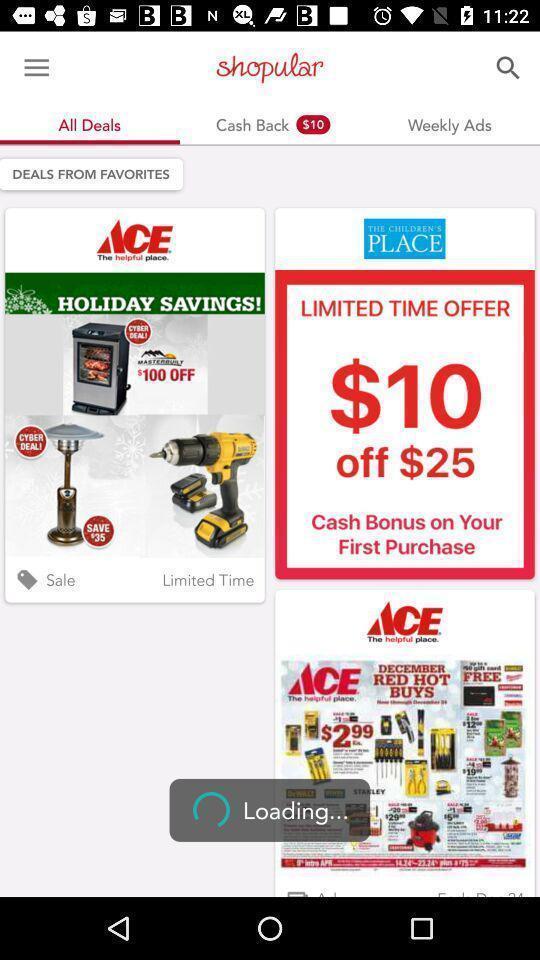Describe the visual elements of this screenshot. Slides displaying various deals in a shopping app. 